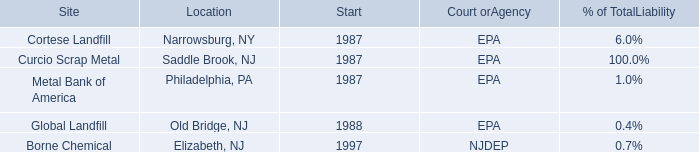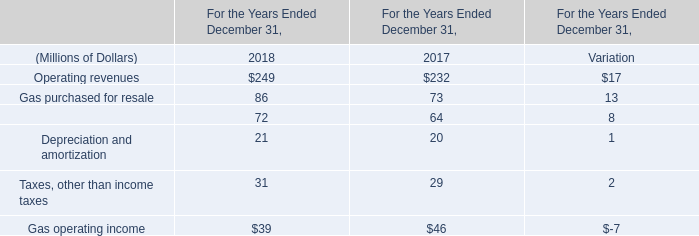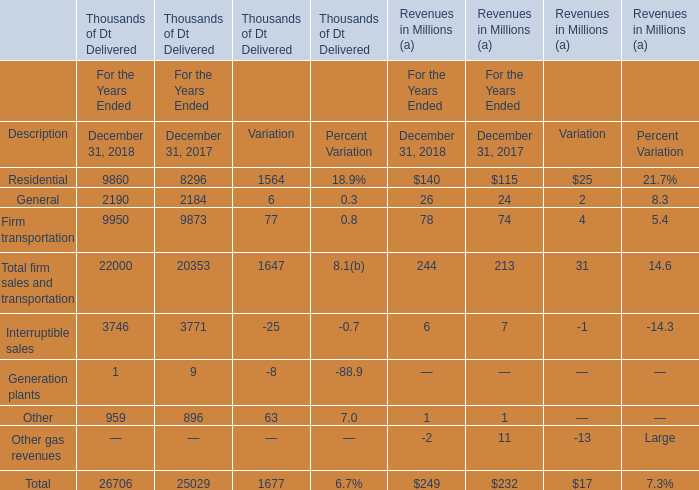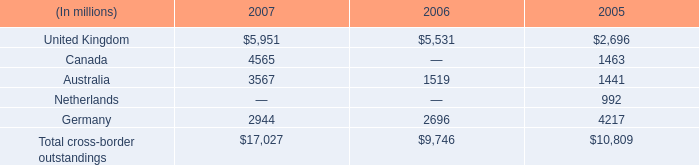what are the total consolidated assets in 2007? 
Computations: (17027 / 12%)
Answer: 141891.66667. 